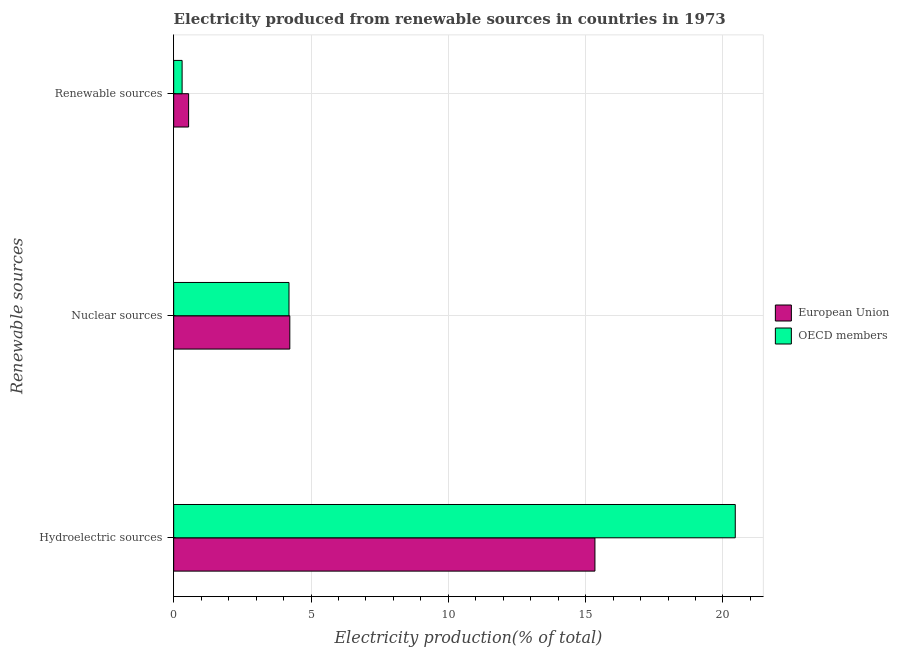How many different coloured bars are there?
Offer a very short reply. 2. How many groups of bars are there?
Make the answer very short. 3. What is the label of the 1st group of bars from the top?
Your answer should be compact. Renewable sources. What is the percentage of electricity produced by renewable sources in OECD members?
Offer a very short reply. 0.31. Across all countries, what is the maximum percentage of electricity produced by renewable sources?
Ensure brevity in your answer.  0.54. Across all countries, what is the minimum percentage of electricity produced by hydroelectric sources?
Give a very brief answer. 15.34. What is the total percentage of electricity produced by hydroelectric sources in the graph?
Your answer should be compact. 35.79. What is the difference between the percentage of electricity produced by hydroelectric sources in European Union and that in OECD members?
Your answer should be very brief. -5.11. What is the difference between the percentage of electricity produced by renewable sources in OECD members and the percentage of electricity produced by hydroelectric sources in European Union?
Your answer should be very brief. -15.03. What is the average percentage of electricity produced by hydroelectric sources per country?
Your answer should be very brief. 17.89. What is the difference between the percentage of electricity produced by hydroelectric sources and percentage of electricity produced by renewable sources in European Union?
Keep it short and to the point. 14.8. In how many countries, is the percentage of electricity produced by renewable sources greater than 1 %?
Ensure brevity in your answer.  0. What is the ratio of the percentage of electricity produced by renewable sources in OECD members to that in European Union?
Offer a terse response. 0.56. Is the difference between the percentage of electricity produced by renewable sources in European Union and OECD members greater than the difference between the percentage of electricity produced by hydroelectric sources in European Union and OECD members?
Give a very brief answer. Yes. What is the difference between the highest and the second highest percentage of electricity produced by nuclear sources?
Offer a very short reply. 0.03. What is the difference between the highest and the lowest percentage of electricity produced by hydroelectric sources?
Your answer should be compact. 5.11. In how many countries, is the percentage of electricity produced by hydroelectric sources greater than the average percentage of electricity produced by hydroelectric sources taken over all countries?
Offer a very short reply. 1. Is the sum of the percentage of electricity produced by renewable sources in OECD members and European Union greater than the maximum percentage of electricity produced by nuclear sources across all countries?
Your answer should be very brief. No. Is it the case that in every country, the sum of the percentage of electricity produced by hydroelectric sources and percentage of electricity produced by nuclear sources is greater than the percentage of electricity produced by renewable sources?
Give a very brief answer. Yes. Are all the bars in the graph horizontal?
Offer a terse response. Yes. What is the title of the graph?
Ensure brevity in your answer.  Electricity produced from renewable sources in countries in 1973. Does "Other small states" appear as one of the legend labels in the graph?
Offer a very short reply. No. What is the label or title of the Y-axis?
Give a very brief answer. Renewable sources. What is the Electricity production(% of total) in European Union in Hydroelectric sources?
Give a very brief answer. 15.34. What is the Electricity production(% of total) in OECD members in Hydroelectric sources?
Offer a very short reply. 20.45. What is the Electricity production(% of total) in European Union in Nuclear sources?
Your response must be concise. 4.23. What is the Electricity production(% of total) in OECD members in Nuclear sources?
Ensure brevity in your answer.  4.2. What is the Electricity production(% of total) in European Union in Renewable sources?
Your response must be concise. 0.54. What is the Electricity production(% of total) of OECD members in Renewable sources?
Keep it short and to the point. 0.31. Across all Renewable sources, what is the maximum Electricity production(% of total) of European Union?
Provide a succinct answer. 15.34. Across all Renewable sources, what is the maximum Electricity production(% of total) in OECD members?
Offer a terse response. 20.45. Across all Renewable sources, what is the minimum Electricity production(% of total) in European Union?
Offer a terse response. 0.54. Across all Renewable sources, what is the minimum Electricity production(% of total) of OECD members?
Your response must be concise. 0.31. What is the total Electricity production(% of total) in European Union in the graph?
Provide a succinct answer. 20.11. What is the total Electricity production(% of total) in OECD members in the graph?
Offer a very short reply. 24.95. What is the difference between the Electricity production(% of total) in European Union in Hydroelectric sources and that in Nuclear sources?
Your response must be concise. 11.11. What is the difference between the Electricity production(% of total) of OECD members in Hydroelectric sources and that in Nuclear sources?
Your answer should be compact. 16.25. What is the difference between the Electricity production(% of total) of European Union in Hydroelectric sources and that in Renewable sources?
Ensure brevity in your answer.  14.79. What is the difference between the Electricity production(% of total) in OECD members in Hydroelectric sources and that in Renewable sources?
Your answer should be compact. 20.14. What is the difference between the Electricity production(% of total) in European Union in Nuclear sources and that in Renewable sources?
Your answer should be very brief. 3.68. What is the difference between the Electricity production(% of total) in OECD members in Nuclear sources and that in Renewable sources?
Give a very brief answer. 3.89. What is the difference between the Electricity production(% of total) of European Union in Hydroelectric sources and the Electricity production(% of total) of OECD members in Nuclear sources?
Your answer should be compact. 11.14. What is the difference between the Electricity production(% of total) in European Union in Hydroelectric sources and the Electricity production(% of total) in OECD members in Renewable sources?
Offer a terse response. 15.03. What is the difference between the Electricity production(% of total) in European Union in Nuclear sources and the Electricity production(% of total) in OECD members in Renewable sources?
Your response must be concise. 3.92. What is the average Electricity production(% of total) in European Union per Renewable sources?
Your answer should be very brief. 6.7. What is the average Electricity production(% of total) of OECD members per Renewable sources?
Provide a succinct answer. 8.32. What is the difference between the Electricity production(% of total) in European Union and Electricity production(% of total) in OECD members in Hydroelectric sources?
Offer a terse response. -5.11. What is the difference between the Electricity production(% of total) of European Union and Electricity production(% of total) of OECD members in Nuclear sources?
Your answer should be compact. 0.03. What is the difference between the Electricity production(% of total) in European Union and Electricity production(% of total) in OECD members in Renewable sources?
Give a very brief answer. 0.24. What is the ratio of the Electricity production(% of total) of European Union in Hydroelectric sources to that in Nuclear sources?
Make the answer very short. 3.63. What is the ratio of the Electricity production(% of total) of OECD members in Hydroelectric sources to that in Nuclear sources?
Keep it short and to the point. 4.87. What is the ratio of the Electricity production(% of total) of European Union in Hydroelectric sources to that in Renewable sources?
Your answer should be compact. 28.2. What is the ratio of the Electricity production(% of total) in OECD members in Hydroelectric sources to that in Renewable sources?
Ensure brevity in your answer.  66.58. What is the ratio of the Electricity production(% of total) of European Union in Nuclear sources to that in Renewable sources?
Ensure brevity in your answer.  7.77. What is the ratio of the Electricity production(% of total) of OECD members in Nuclear sources to that in Renewable sources?
Ensure brevity in your answer.  13.67. What is the difference between the highest and the second highest Electricity production(% of total) in European Union?
Your response must be concise. 11.11. What is the difference between the highest and the second highest Electricity production(% of total) in OECD members?
Your answer should be compact. 16.25. What is the difference between the highest and the lowest Electricity production(% of total) in European Union?
Your response must be concise. 14.79. What is the difference between the highest and the lowest Electricity production(% of total) in OECD members?
Your answer should be compact. 20.14. 